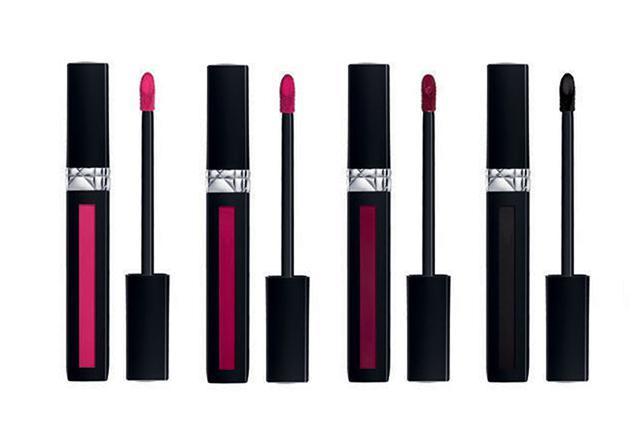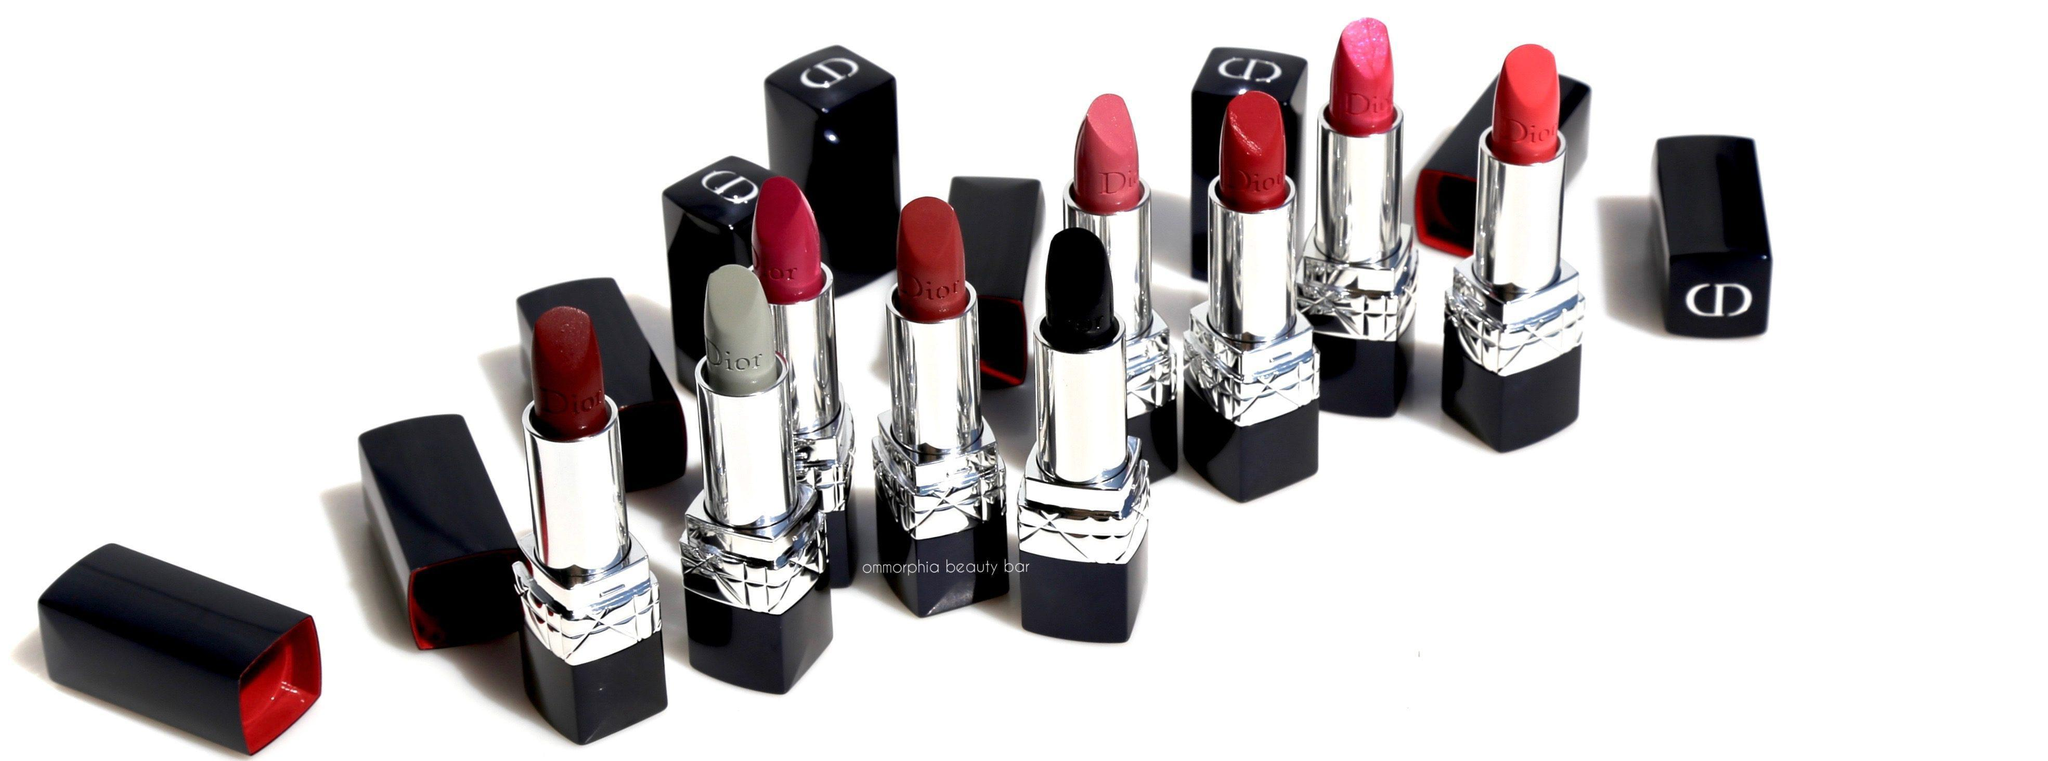The first image is the image on the left, the second image is the image on the right. For the images shown, is this caption "In one of the images, all the items are laying on their sides." true? Answer yes or no. No. The first image is the image on the left, the second image is the image on the right. For the images displayed, is the sentence "There are at least 9 objects standing straight up in the right image." factually correct? Answer yes or no. Yes. 